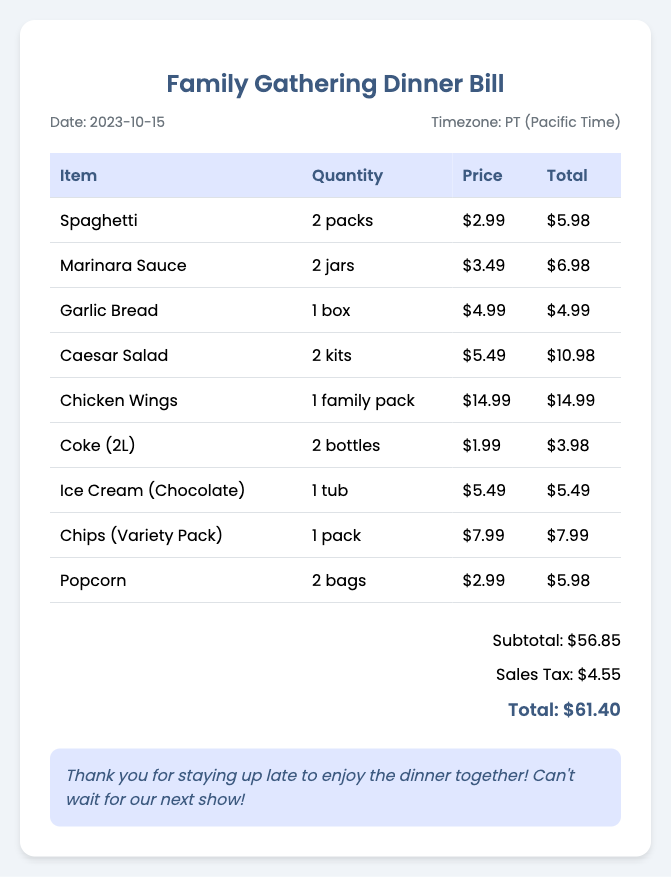What is the date of the bill? The bill date is mentioned at the top of the document as 2023-10-15.
Answer: 2023-10-15 How many packs of Spaghetti were purchased? The document specifies that 2 packs of Spaghetti were bought.
Answer: 2 packs What is the total amount of sales tax? The sales tax is calculated and listed as $4.55 in the summary.
Answer: $4.55 Which item was purchased in a family pack? The document indicates that Chicken Wings were purchased in a family pack.
Answer: Chicken Wings What is the total cost of the dinner? The total cost is provided in the summary as $61.40.
Answer: $61.40 How many jars of Marinara Sauce were included? The bill states that 2 jars of Marinara Sauce were purchased.
Answer: 2 jars What was the price of the Ice Cream? The cost for the Ice Cream is specified as $5.49 in the table.
Answer: $5.49 Which item had the highest price? The Chicken Wings are listed as the item with the highest price at $14.99.
Answer: Chicken Wings What is included in the remarks section? The remarks express gratitude and excitement for future gatherings, mentioning enjoying the dinner together.
Answer: Thank you for staying up late to enjoy the dinner together! Can't wait for our next show! 